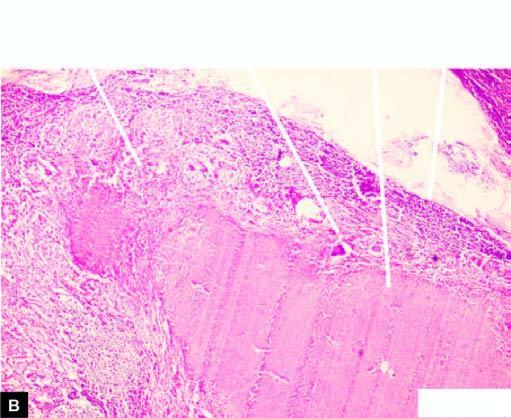what does cut section of matted mass of lymph nodes show?
Answer the question using a single word or phrase. Merging capsules and large areas of caseation necrosis 